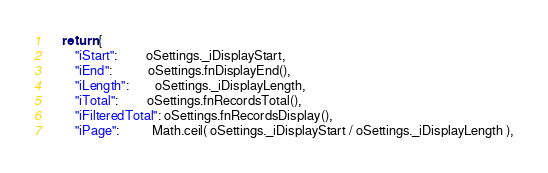<code> <loc_0><loc_0><loc_500><loc_500><_JavaScript_>	return {
		"iStart":         oSettings._iDisplayStart,
		"iEnd":           oSettings.fnDisplayEnd(),
		"iLength":        oSettings._iDisplayLength,
		"iTotal":         oSettings.fnRecordsTotal(),
		"iFilteredTotal": oSettings.fnRecordsDisplay(),
		"iPage":          Math.ceil( oSettings._iDisplayStart / oSettings._iDisplayLength ),</code> 